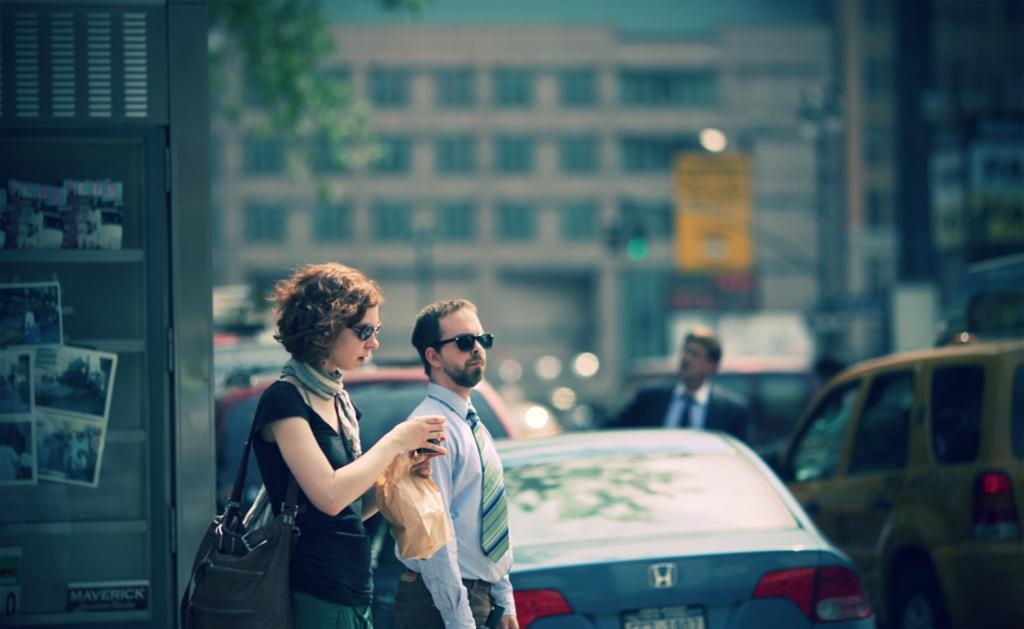What type of vehicles can be seen in the image? There are cars in the image. Who or what else is present in the image? There are people and a banner in the image. What type of plant is visible in the image? There is a tree in the image. What objects might be used for displaying photos? There are photo frames in the image. What type of vegetable is being used as a level in the image? There is no vegetable being used as a level in the image. How does the nerve affect the people in the image? There is no mention of a nerve affecting the people in the image. 